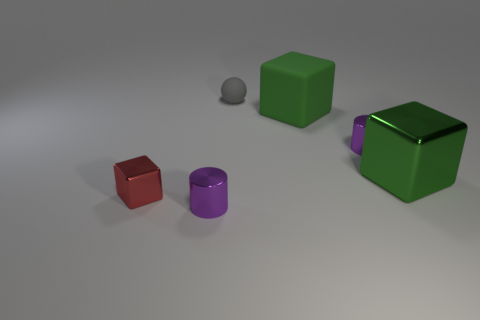What is the material of the large green thing that is behind the tiny purple cylinder that is right of the purple object in front of the big metallic thing?
Offer a very short reply. Rubber. What is the material of the tiny cylinder to the left of the big object to the left of the large green shiny cube?
Your response must be concise. Metal. Is the number of green rubber cubes that are in front of the red block less than the number of small brown rubber balls?
Make the answer very short. No. There is a big object to the right of the matte cube; what is its shape?
Provide a short and direct response. Cube. Does the red metal thing have the same size as the purple metal object that is left of the gray rubber sphere?
Ensure brevity in your answer.  Yes. Is there a tiny thing made of the same material as the tiny red cube?
Provide a succinct answer. Yes. How many balls are green objects or green rubber objects?
Offer a very short reply. 0. There is a big matte block behind the green shiny thing; is there a green rubber thing that is behind it?
Give a very brief answer. No. Are there fewer small shiny cylinders than red blocks?
Give a very brief answer. No. How many red shiny things are the same shape as the gray rubber object?
Provide a succinct answer. 0. 